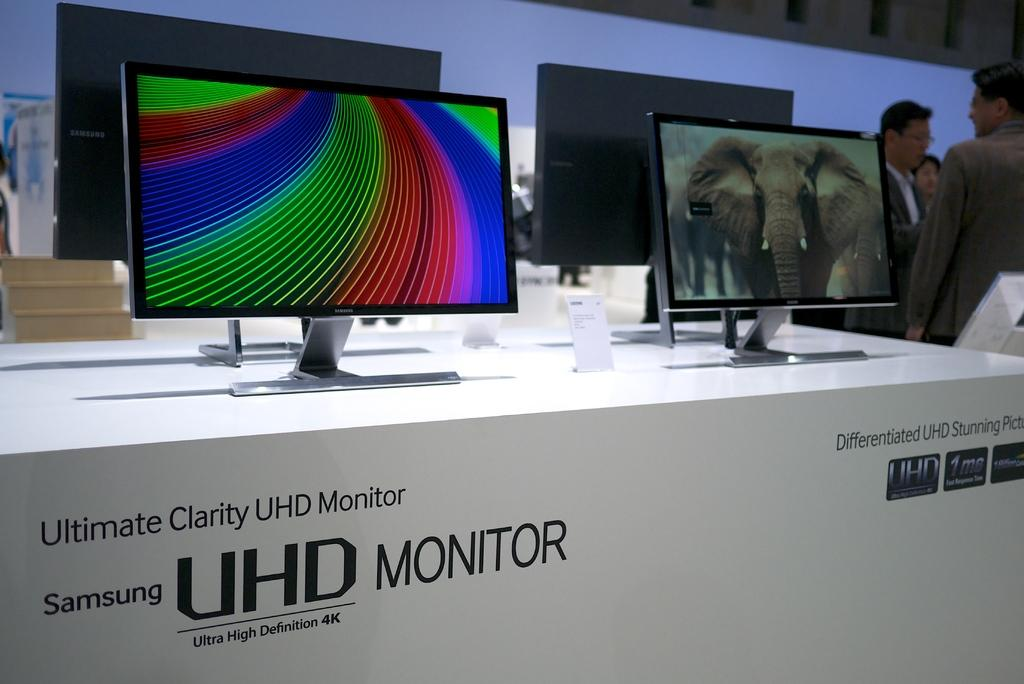<image>
Relay a brief, clear account of the picture shown. Samsung UHD monitors are our on display on a counter. 